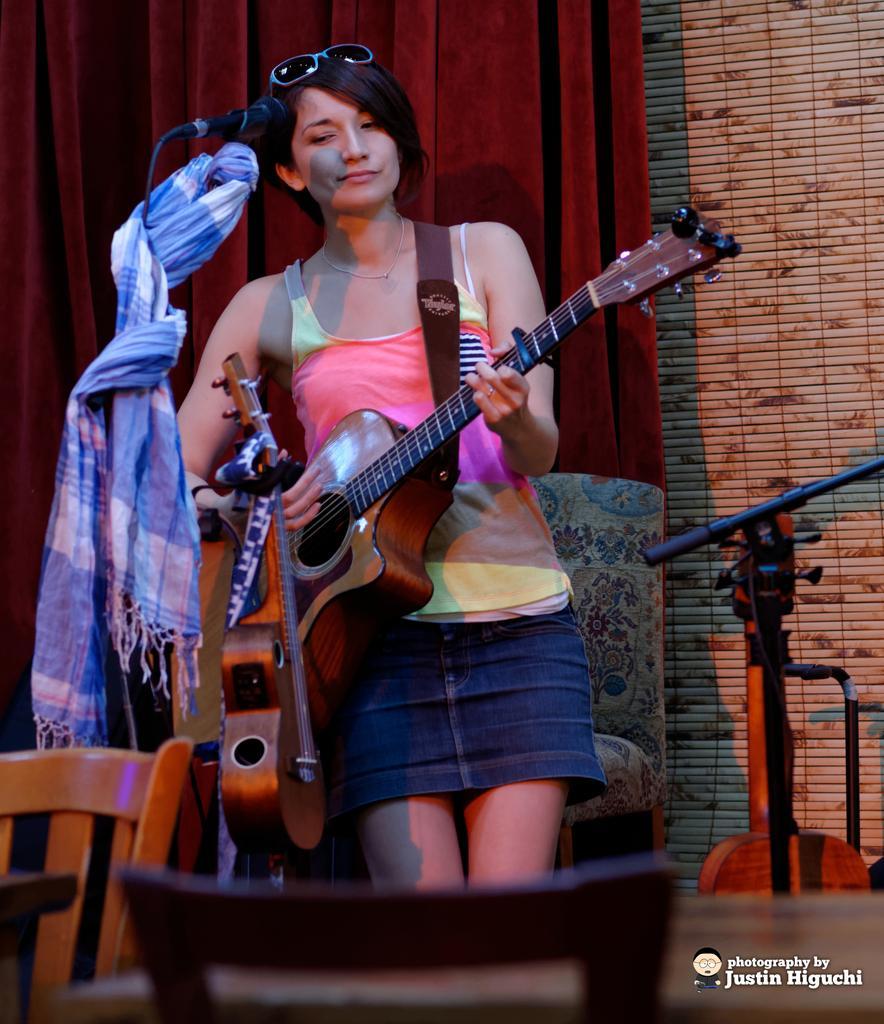In one or two sentences, can you explain what this image depicts? This woman is playing a guitar. In-front of this woman there is a mic. This is a red curtain. We can able to see chair and musical instrument. 